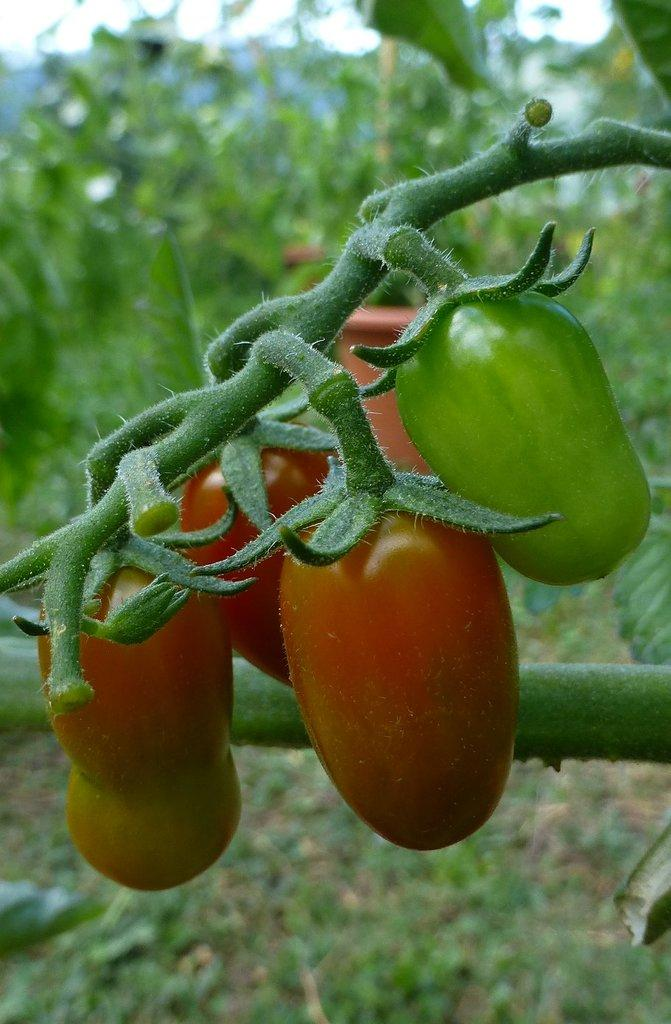What type of vegetable is present in the image? There are capsicums in the image. What can be seen in the background of the image? There are planets on the ground in the background of the image. What type of cheese is being served for breakfast in the image? There is no cheese or reference to breakfast present in the image. 